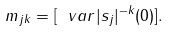<formula> <loc_0><loc_0><loc_500><loc_500>m _ { j k } = [ \ v a r | s _ { j } | ^ { - k } ( 0 ) ] .</formula> 